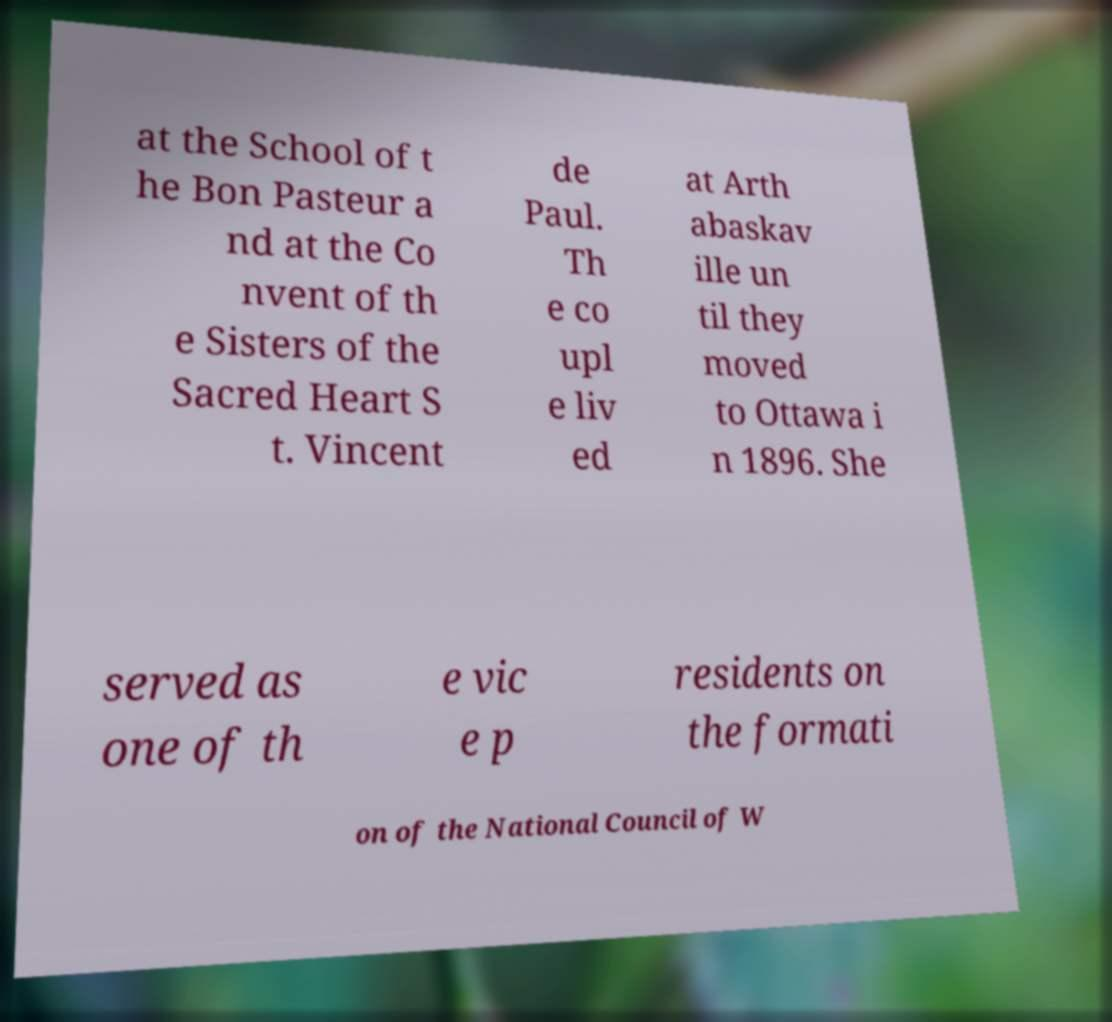For documentation purposes, I need the text within this image transcribed. Could you provide that? at the School of t he Bon Pasteur a nd at the Co nvent of th e Sisters of the Sacred Heart S t. Vincent de Paul. Th e co upl e liv ed at Arth abaskav ille un til they moved to Ottawa i n 1896. She served as one of th e vic e p residents on the formati on of the National Council of W 